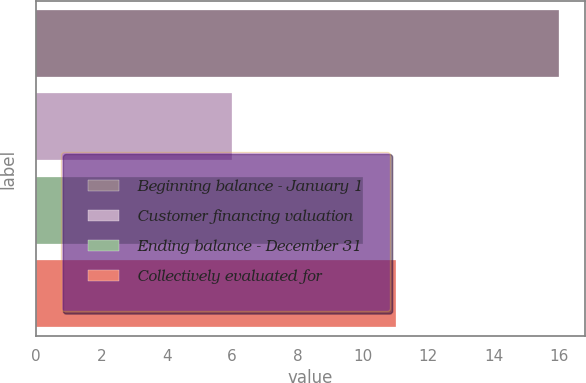Convert chart to OTSL. <chart><loc_0><loc_0><loc_500><loc_500><bar_chart><fcel>Beginning balance - January 1<fcel>Customer financing valuation<fcel>Ending balance - December 31<fcel>Collectively evaluated for<nl><fcel>16<fcel>6<fcel>10<fcel>11<nl></chart> 